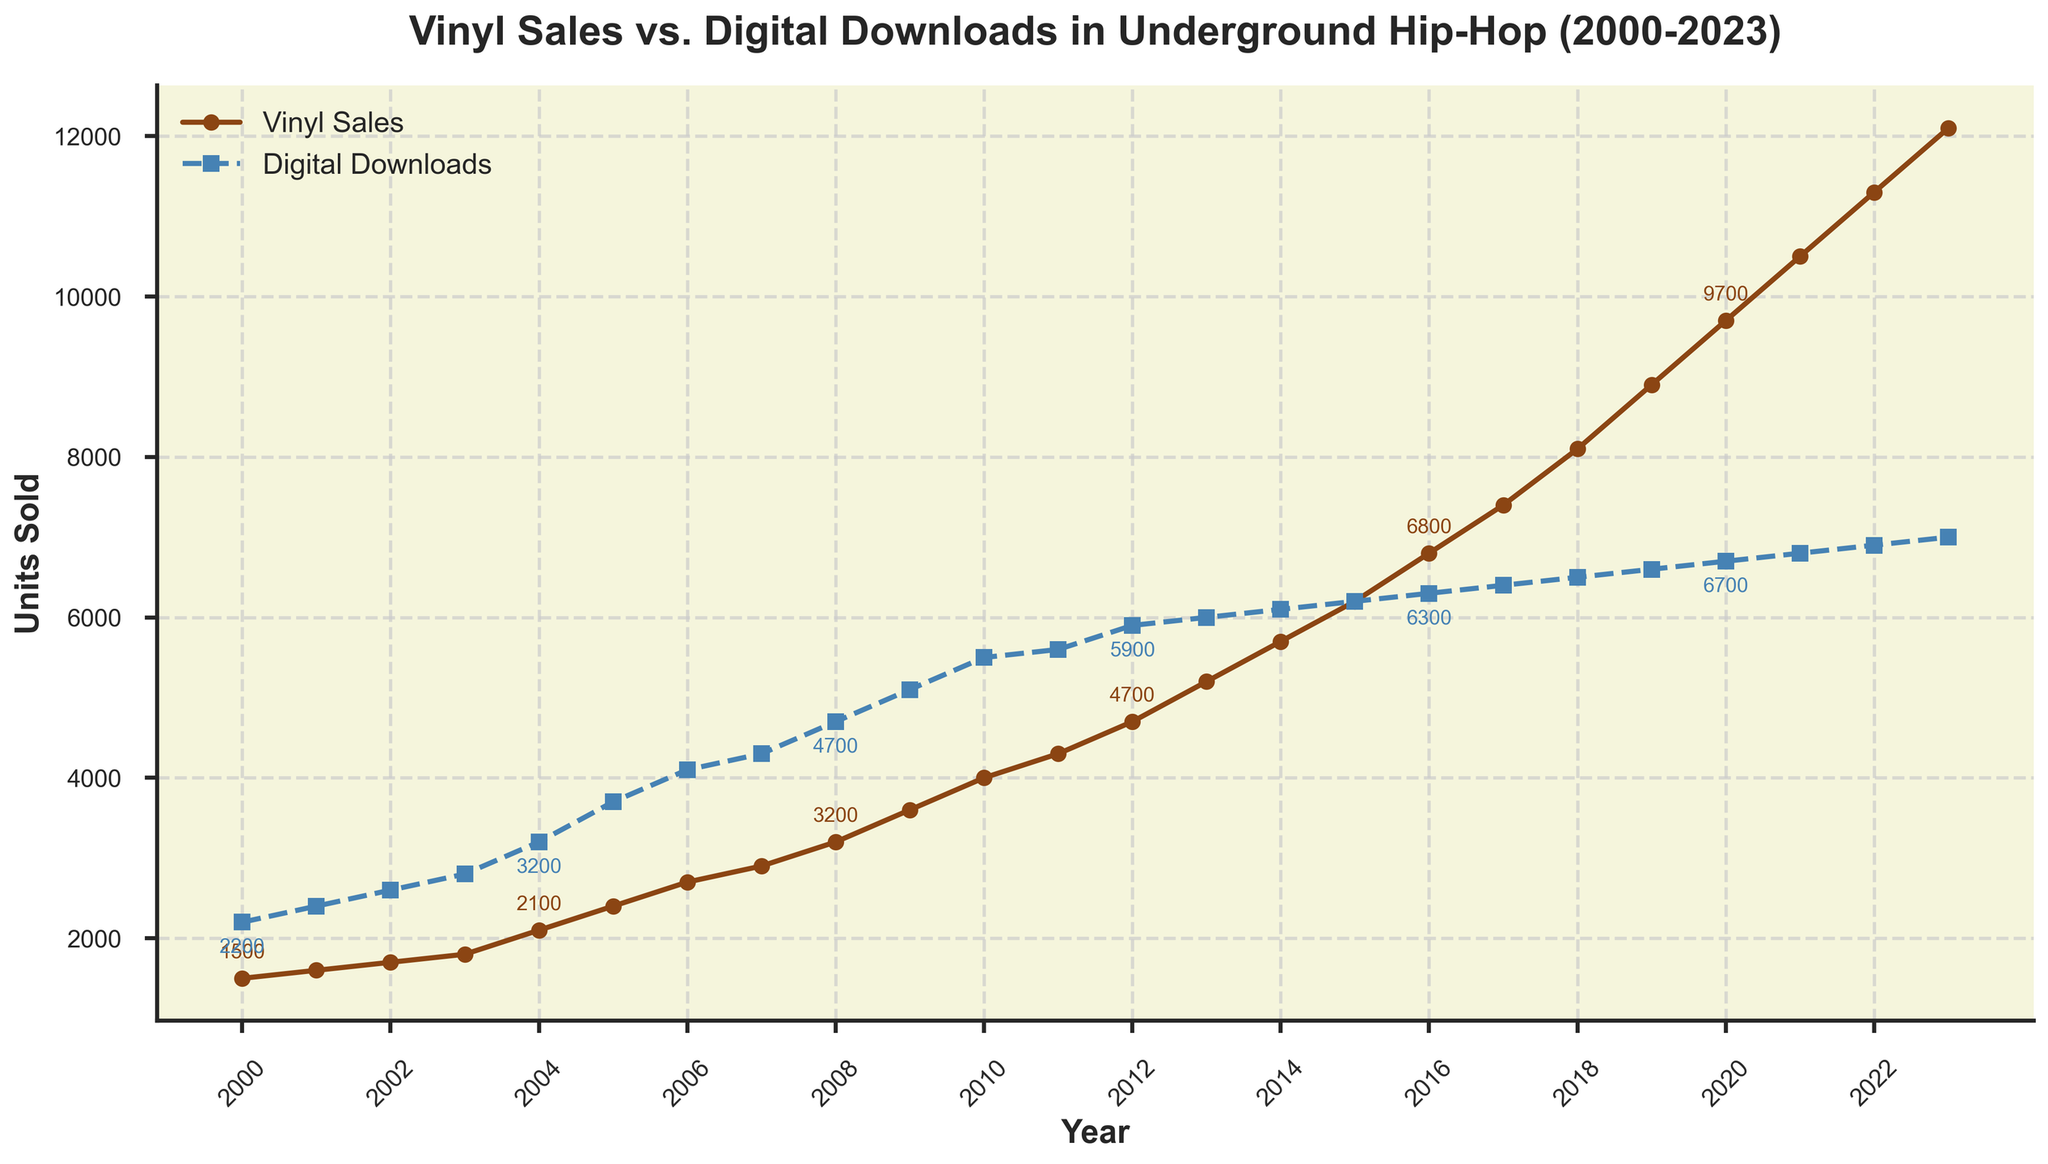What is the title of the plot? The title of the plot is usually at the top center and is visually larger and bold. Here, the title is clearly written at the top of the figure.
Answer: Vinyl Sales vs. Digital Downloads in Underground Hip-Hop (2000-2023) How many distinct years are represented in the plot? By counting the number of data points along the x-axis, which represents the years.
Answer: 24 What color represents Vinyl Sales? The legend in the plot usually indicates which line corresponds to which category. The color corresponding to Vinyl Sales will be mentioned in the legend.
Answer: Brown In which year did Vinyl Sales surpass Digital Downloads? Look for the year where the line representing Vinyl Sales (Brown) crosses above the line representing Digital Downloads (Blue).
Answer: 2015 What are the Vinyl Sales and Digital Downloads values in 2010? Follow the lines for Vinyl Sales and Digital Downloads and find the data points at the year 2010 on the x-axis. Look at the respective values annotated on the points or the y-axis value.
Answer: Vinyl Sales: 4000, Digital Downloads: 5500 What is the difference in units between Vinyl Sales and Digital Downloads in 2023? Use the data points for 2023 and subtract the number of Digital Downloads from the number of Vinyl Sales.
Answer: 5100 Which year shows the biggest difference between Vinyl Sales and Digital Downloads? By visually assessing the distance between the two lines on the plot, find the year where this distance is most significant. Then, check the point annotations to verify.
Answer: 2023 How has the trend in Vinyl Sales changed over the years 2000-2023? Observe the general slope of the Vinyl Sales line (Brown), noting increases or decreases. Identify whether it's a consistent trend or if there were any significant shifts or changes.
Answer: Consistently increasing What is the average number of Digital Downloads from 2000 to 2023? Sum the Digital Downloads from 2000 to 2023 and divide by the number of years (24).
Answer: 5612.5 In which decade did Vinyl Sales grow the most rapidly? Examine the growth of the Vinyl Sales line in each decade (2000-2010, 2010-2020, 2020-2023) by comparing the vertical distance covered by the line.
Answer: 2010-2020 